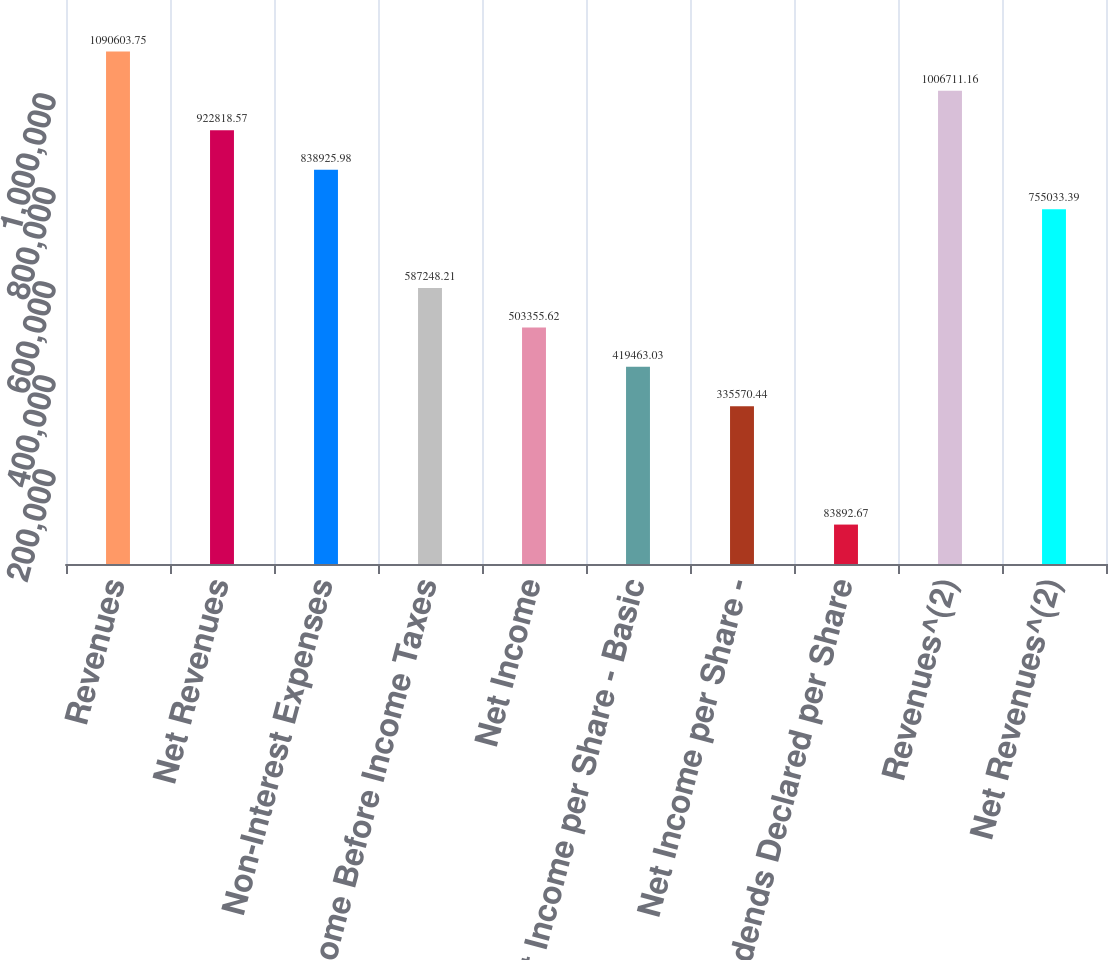Convert chart to OTSL. <chart><loc_0><loc_0><loc_500><loc_500><bar_chart><fcel>Revenues<fcel>Net Revenues<fcel>Non-Interest Expenses<fcel>Income Before Income Taxes<fcel>Net Income<fcel>Net Income per Share - Basic<fcel>Net Income per Share -<fcel>Dividends Declared per Share<fcel>Revenues^(2)<fcel>Net Revenues^(2)<nl><fcel>1.0906e+06<fcel>922819<fcel>838926<fcel>587248<fcel>503356<fcel>419463<fcel>335570<fcel>83892.7<fcel>1.00671e+06<fcel>755033<nl></chart> 